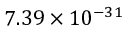<formula> <loc_0><loc_0><loc_500><loc_500>7 . 3 9 \times 1 0 ^ { - 3 1 }</formula> 